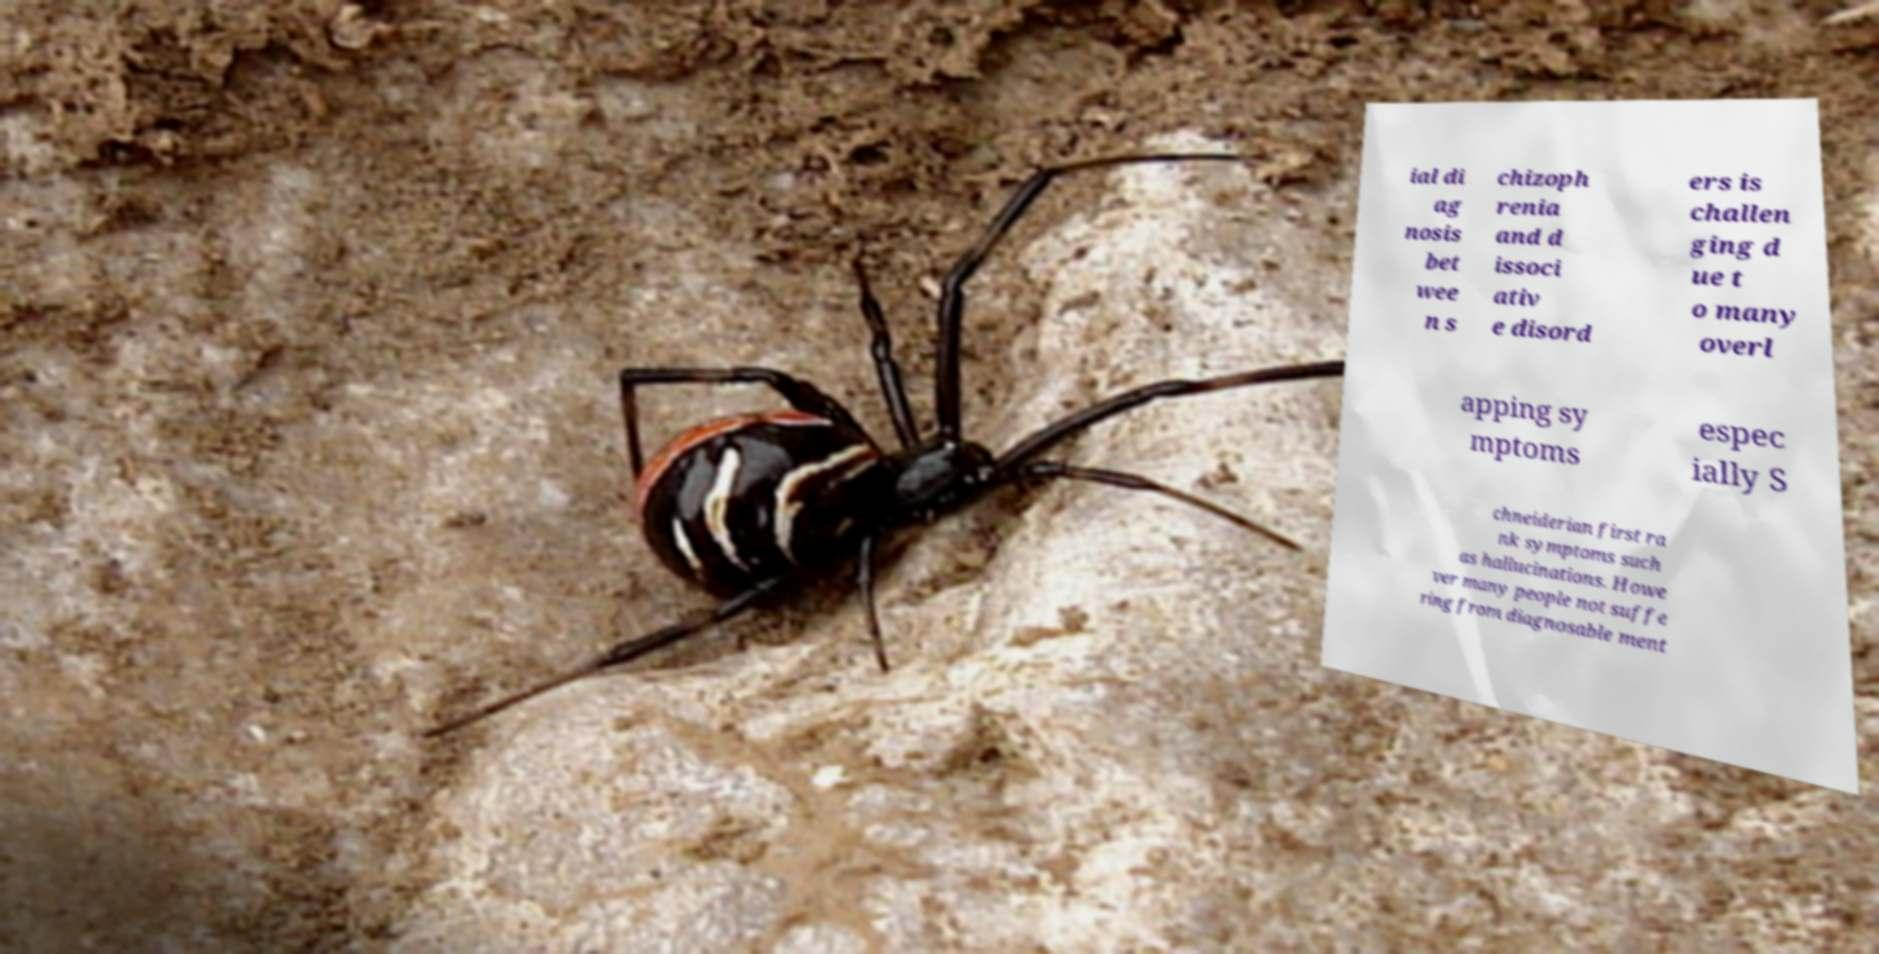Could you assist in decoding the text presented in this image and type it out clearly? ial di ag nosis bet wee n s chizoph renia and d issoci ativ e disord ers is challen ging d ue t o many overl apping sy mptoms espec ially S chneiderian first ra nk symptoms such as hallucinations. Howe ver many people not suffe ring from diagnosable ment 